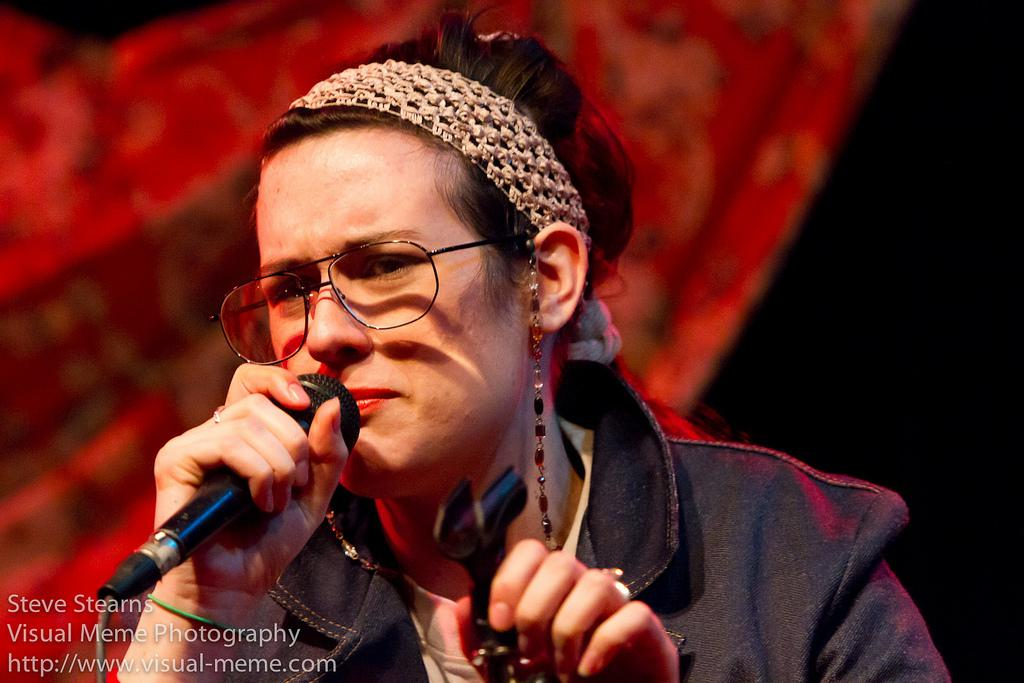What is the main subject of the image? There is a woman standing in the center of the image. What is the woman holding in the image? The woman is holding a mic. What can be seen in the background of the image? There is a cloth in the background of the image. Is there any text present in the image? Yes, there is a text in the bottom left corner of the image. Can you see any hills in the image? There are no hills visible in the image. What type of soda is the woman drinking in the image? There is no soda present in the image; the woman is holding a mic. 